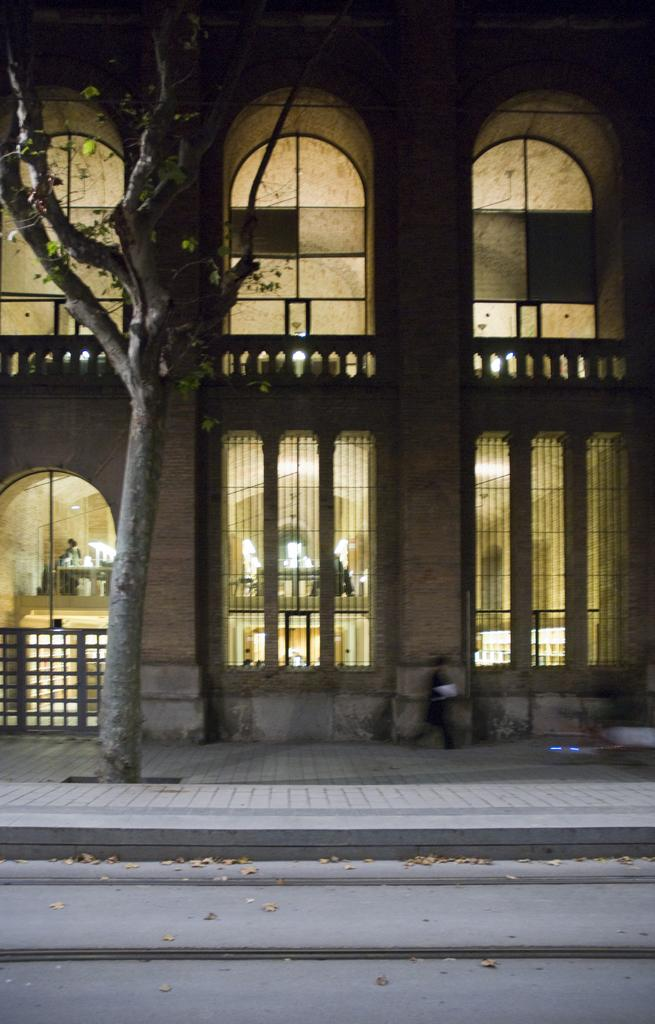What type of structure is present in the image? There is a building in the image. What feature can be seen on the building? The building has windows. What else is visible in the image besides the building? There are lights visible in the image. What type of vegetation is on the left side of the image? There is a tree on the left side of the image. Can you see a scarecrow standing near the tree in the image? No, there is no scarecrow present in the image. What type of rail can be seen connecting the building to the sea in the image? There is no rail or sea visible in the image; it only features a building, lights, and a tree. 